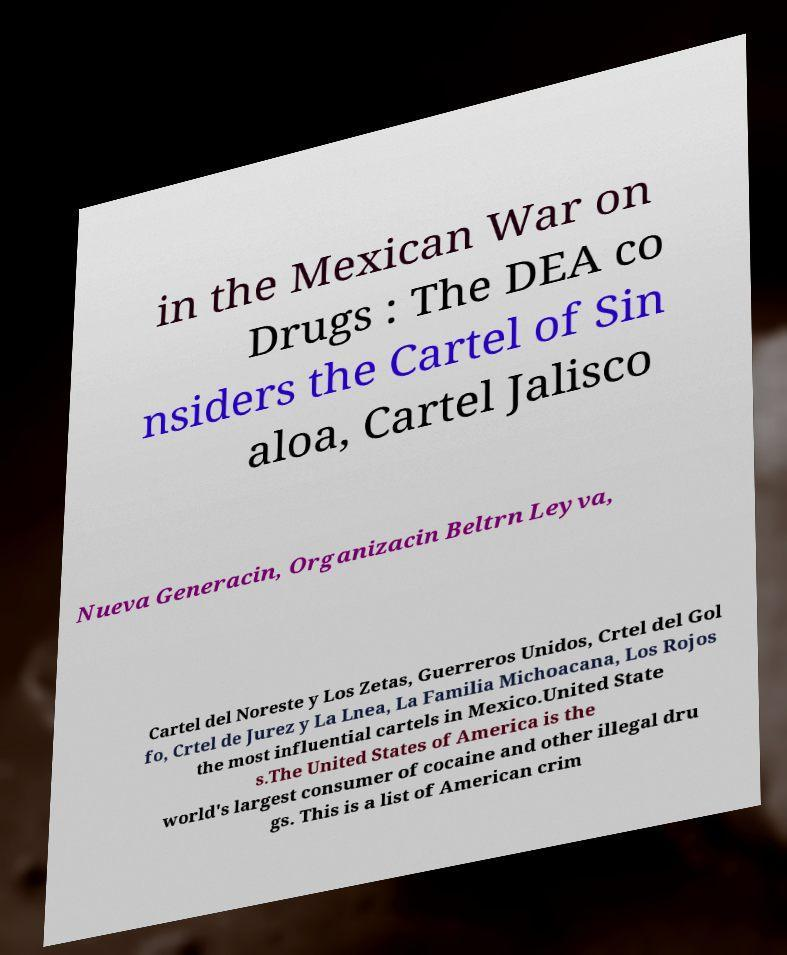Please identify and transcribe the text found in this image. in the Mexican War on Drugs : The DEA co nsiders the Cartel of Sin aloa, Cartel Jalisco Nueva Generacin, Organizacin Beltrn Leyva, Cartel del Noreste y Los Zetas, Guerreros Unidos, Crtel del Gol fo, Crtel de Jurez y La Lnea, La Familia Michoacana, Los Rojos the most influential cartels in Mexico.United State s.The United States of America is the world's largest consumer of cocaine and other illegal dru gs. This is a list of American crim 